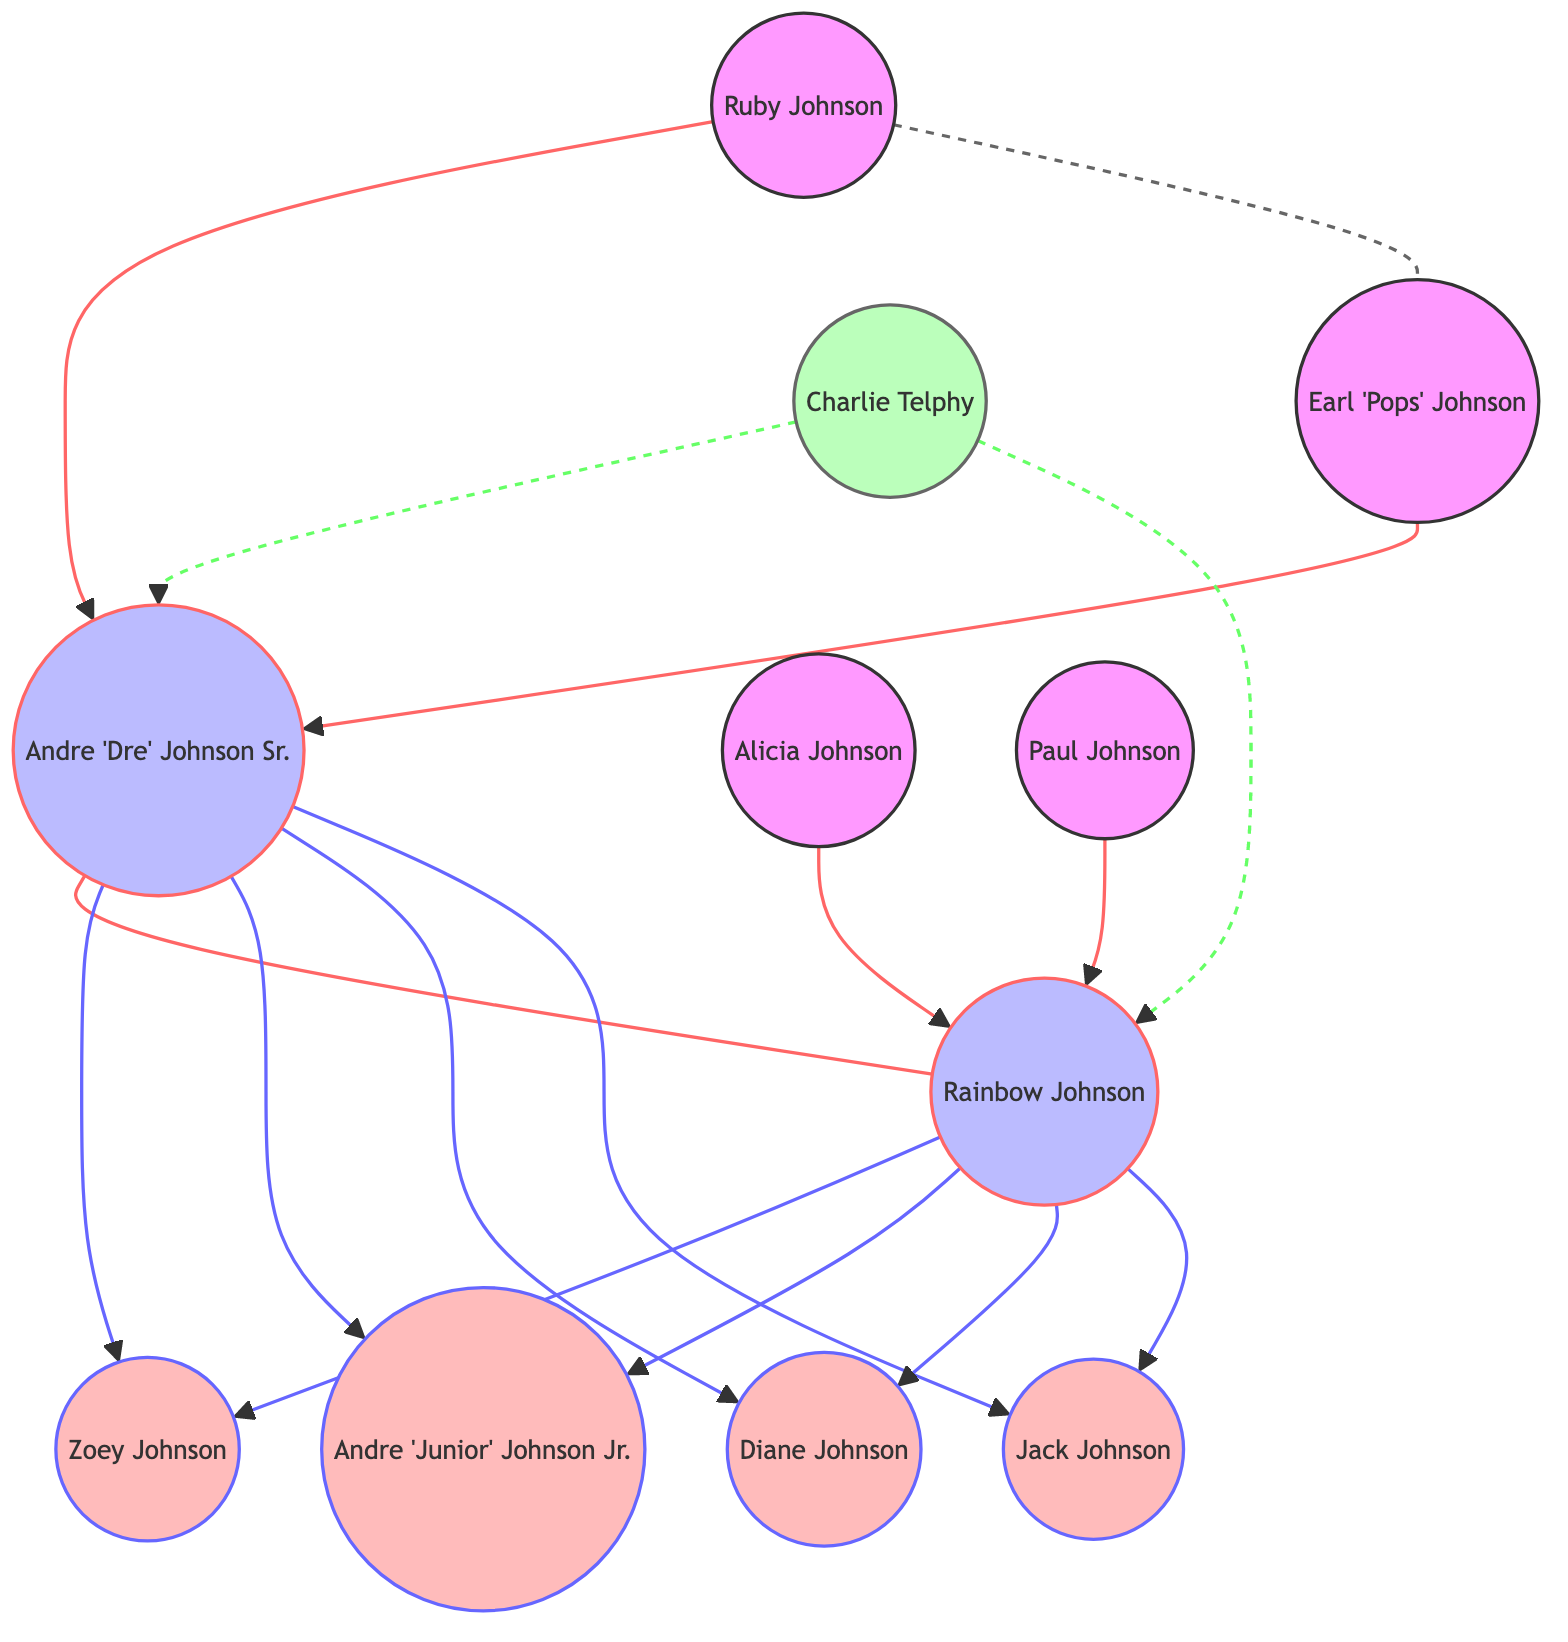What is the relationship between Dre and Rainbow? The diagram shows a solid line connecting Dre and Rainbow with the label "Spouse" indicating their marital relationship.
Answer: Spouse How many children does Dre have? Dre is connected to four nodes labeled as Zoey, Junior, Diane, and Jack, indicating he is a parent to each of them. Therefore, he has four children.
Answer: 4 Who is the parent of Zoey? From the diagram, both Dre and Rainbow are connected to Zoey with arrows labeled "Parent," indicating they are both her parents.
Answer: Dre and Rainbow What type of relationship exists between Charlie and Rainbow? The diagram shows a dashed line between Charlie and Rainbow labeled "Friend," indicating a friendship between them.
Answer: Friend Which character is both a parent to Dre and also has a divorce relationship with Ruby? The diagram shows Pops connected to Dre with a solid line labeled "Parent," and Ruby connected to Pops with a dashed line labeled "Divorced." This indicates that Pops is Dre's parent and has a divorce relationship with Ruby.
Answer: Pops How many parents does Rainbow have? The diagram shows two lines leading to Rainbow from BowMum and BowDad, both labeled "Parent," indicating that she has two parents.
Answer: 2 What is the relationship between Ruby and Dre? The diagram shows a solid line connecting Ruby to Dre labeled "Parent," indicating that Ruby is Dre's parent.
Answer: Parent Who is the parent of Junior? The diagram illustrates that both Dre and Rainbow have arrows leading to Junior labeled "Parent," demonstrating that they are Junior's parents.
Answer: Dre and Rainbow Is Charlie a relative of Dre? The diagram depicts a dashed line between Charlie and Dre labeled "Friend," indicating that Charlie is not a relative but a friend of Dre.
Answer: No 